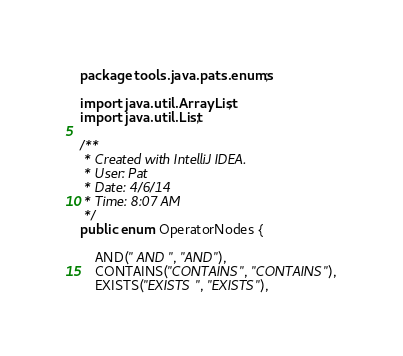Convert code to text. <code><loc_0><loc_0><loc_500><loc_500><_Java_>package tools.java.pats.enums;

import java.util.ArrayList;
import java.util.List;

/**
 * Created with IntelliJ IDEA.
 * User: Pat
 * Date: 4/6/14
 * Time: 8:07 AM
 */
public enum OperatorNodes {

    AND(" AND ", "AND"),
    CONTAINS("CONTAINS", "CONTAINS"),
    EXISTS("EXISTS ", "EXISTS"),</code> 